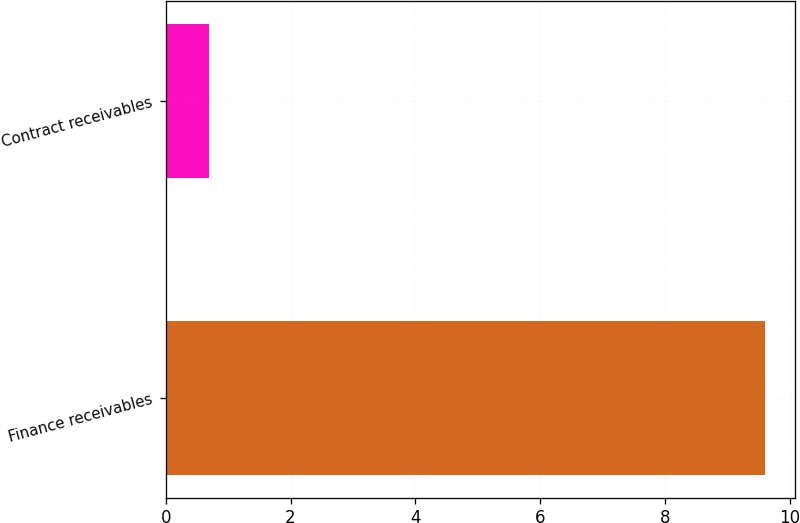Convert chart. <chart><loc_0><loc_0><loc_500><loc_500><bar_chart><fcel>Finance receivables<fcel>Contract receivables<nl><fcel>9.6<fcel>0.7<nl></chart> 